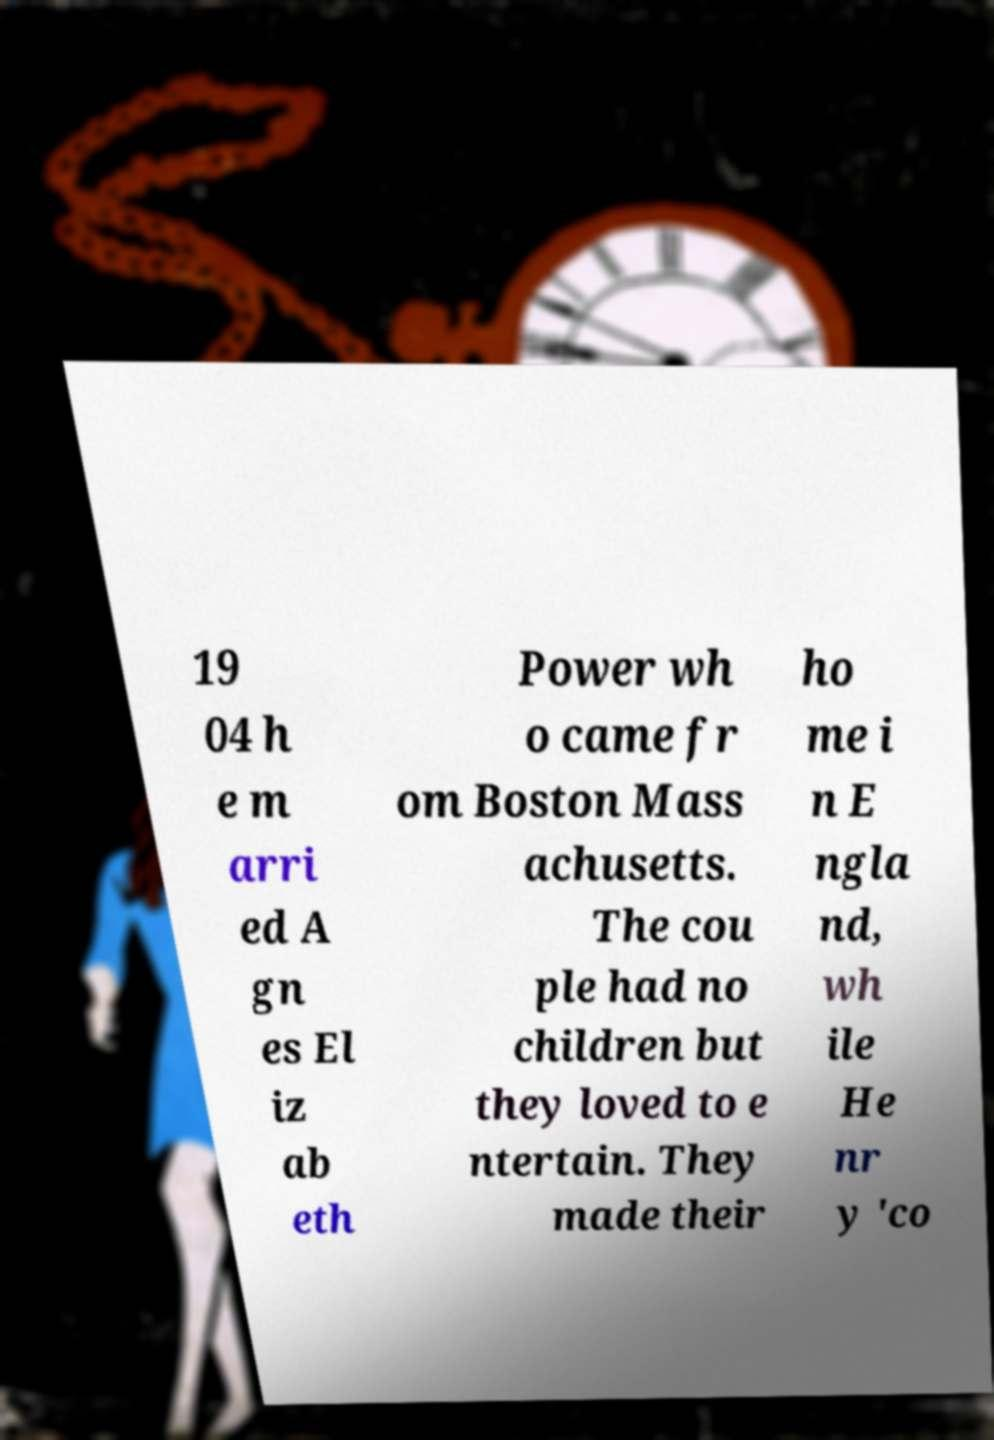Can you read and provide the text displayed in the image?This photo seems to have some interesting text. Can you extract and type it out for me? 19 04 h e m arri ed A gn es El iz ab eth Power wh o came fr om Boston Mass achusetts. The cou ple had no children but they loved to e ntertain. They made their ho me i n E ngla nd, wh ile He nr y 'co 